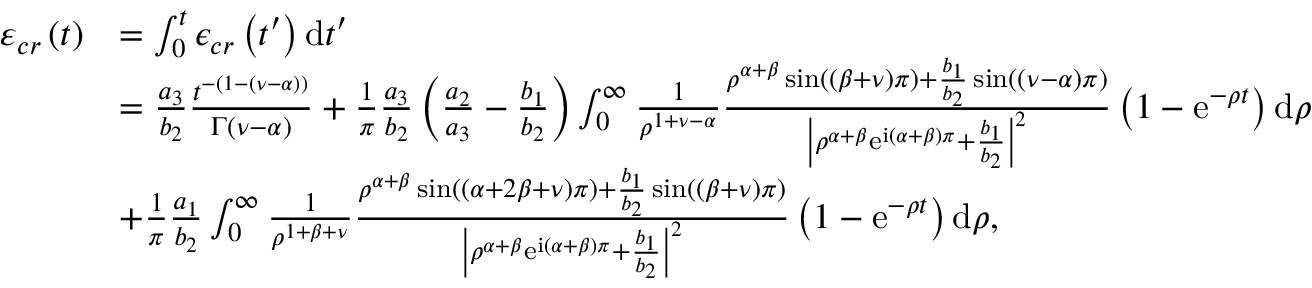Convert formula to latex. <formula><loc_0><loc_0><loc_500><loc_500>\begin{array} { r l } { \varepsilon _ { c r } \left ( t \right ) } & { = \int _ { 0 } ^ { t } \epsilon _ { c r } \left ( t ^ { \prime } \right ) d t ^ { \prime } } \\ & { = \frac { a _ { 3 } } { b _ { 2 } } \frac { t ^ { - \left ( 1 - \left ( \nu - \alpha \right ) \right ) } } { \Gamma \left ( \nu - \alpha \right ) } + \frac { 1 } { \pi } \frac { a _ { 3 } } { b _ { 2 } } \left ( \frac { a _ { 2 } } { a _ { 3 } } - \frac { b _ { 1 } } { b _ { 2 } } \right ) \int _ { 0 } ^ { \infty } \frac { 1 } { \rho ^ { 1 + \nu - \alpha } } \frac { \rho ^ { \alpha + \beta } \sin \left ( \left ( \beta + \nu \right ) \pi \right ) + \frac { b _ { 1 } } { b _ { 2 } } \sin \left ( \left ( \nu - \alpha \right ) \pi \right ) } { \left | \rho ^ { \alpha + \beta } e ^ { i \left ( \alpha + \beta \right ) \pi } + \frac { b _ { 1 } } { b _ { 2 } } \right | ^ { 2 } } \left ( 1 - e ^ { - \rho t } \right ) d \rho } \\ & { + \frac { 1 } { \pi } \frac { a _ { 1 } } { b _ { 2 } } \int _ { 0 } ^ { \infty } \frac { 1 } { \rho ^ { 1 + \beta + \nu } } \frac { \rho ^ { \alpha + \beta } \sin \left ( \left ( \alpha + 2 \beta + \nu \right ) \pi \right ) + \frac { b _ { 1 } } { b _ { 2 } } \sin \left ( \left ( \beta + \nu \right ) \pi \right ) } { \left | \rho ^ { \alpha + \beta } e ^ { i \left ( \alpha + \beta \right ) \pi } + \frac { b _ { 1 } } { b _ { 2 } } \right | ^ { 2 } } \left ( 1 - e ^ { - \rho t } \right ) d \rho , } \end{array}</formula> 